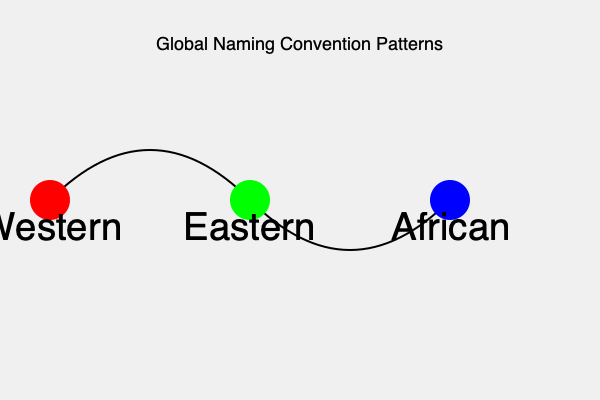Based on the diagram, which region is most likely to have naming conventions that emphasize family lineage and clan affiliations? To answer this question, we need to analyze the information provided in the diagram and apply our knowledge of global naming conventions:

1. The diagram shows three regions: Western, Eastern, and African.
2. Each region is represented by a colored circle on a curved line, suggesting a continuum or relationship between these naming convention patterns.
3. In linguistic anthropology, we know that:
   a. Western naming conventions often prioritize individual identity.
   b. Eastern naming conventions frequently emphasize family relationships.
   c. African naming conventions often reflect deep cultural ties, including clan and lineage.
4. Among these three regions, African naming conventions are most strongly associated with emphasizing family lineage and clan affiliations.
5. This is due to the importance of extended family structures and ancestral connections in many African cultures.
6. The blue circle representing African naming conventions is positioned at the end of the continuum, suggesting it may have the most distinct characteristics in this aspect.

Therefore, based on the information provided and our understanding of global naming practices, the African region is most likely to have naming conventions that emphasize family lineage and clan affiliations.
Answer: African 